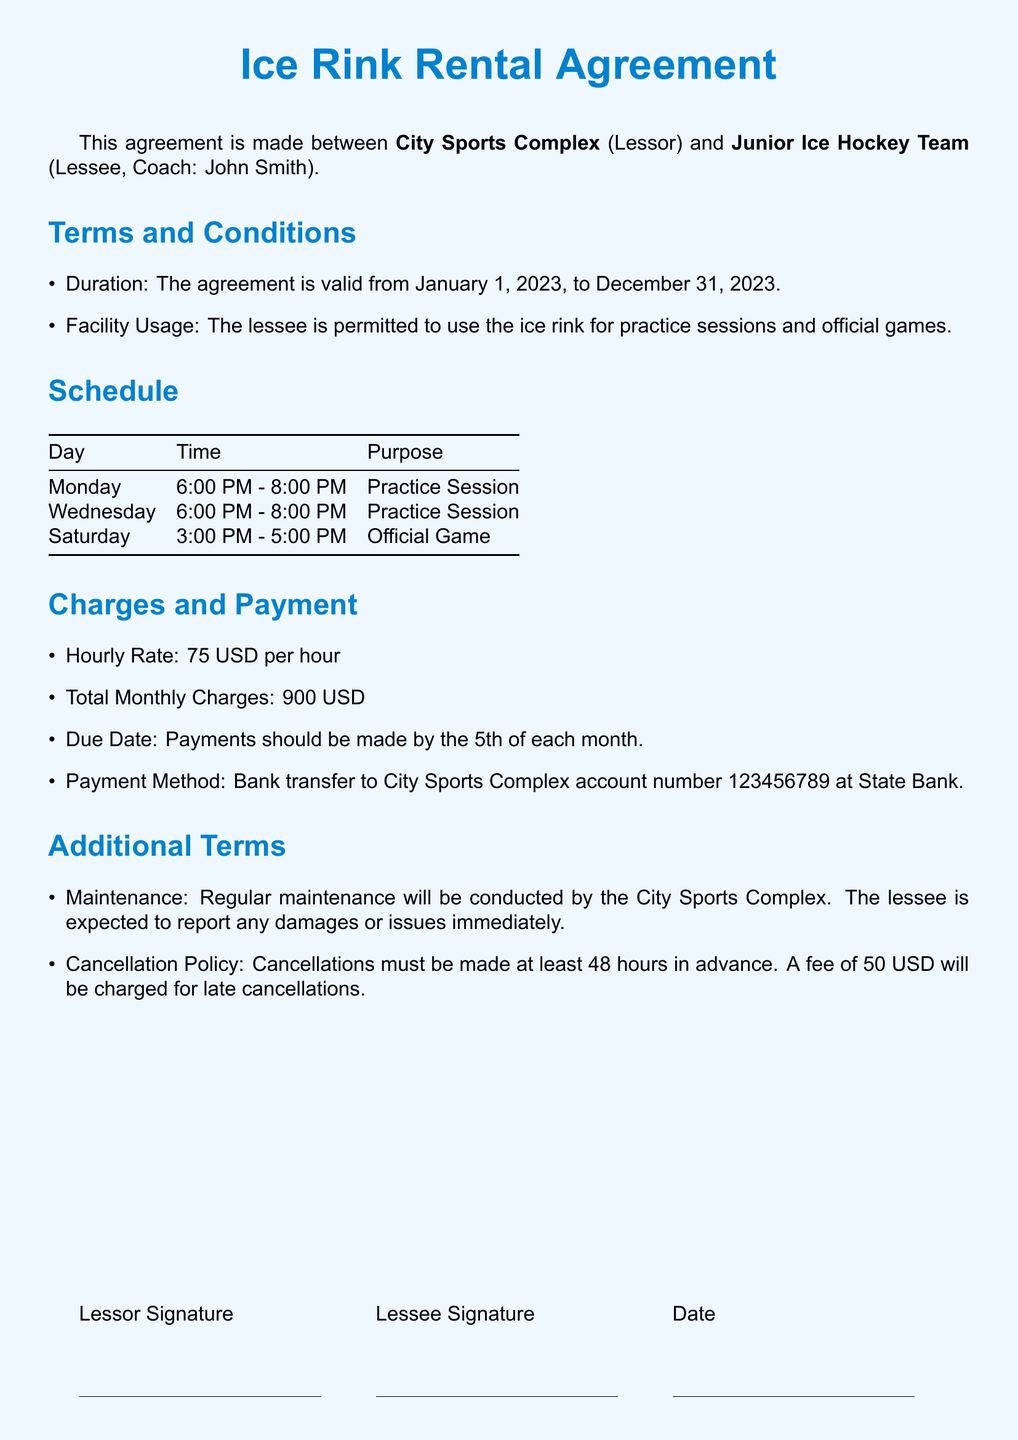What is the duration of the agreement? The duration of the agreement is specified in the document as the period that it is valid. The agreement is valid from January 1, 2023, to December 31, 2023.
Answer: January 1, 2023, to December 31, 2023 What is the hourly rate for renting the ice rink? The hourly rate for using the ice rink is mentioned in the Charges section of the document.
Answer: 75 USD per hour How many practice sessions are scheduled per week? The schedule lists the number of practice sessions held during a week. The document shows two practice sessions on Monday and Wednesday.
Answer: 2 What is the total monthly charge for ice rink rental? The total monthly charges are outlined in the Charges section of the document.
Answer: 900 USD What is the cancellation fee for late cancellations? The cancellation fee for late cancellations is specified in the Additional Terms section of the document.
Answer: 50 USD On which day is the official game scheduled? The schedule mentions the specific day allocated for the official game. It is listed on Saturday.
Answer: Saturday Who is the coach of the Junior Ice Hockey Team? The agreement specifies the name of the coach under the Lessee section.
Answer: John Smith When is the payment due? The due date for payments is outlined in the Charges and Payment section of the document.
Answer: 5th of each month 